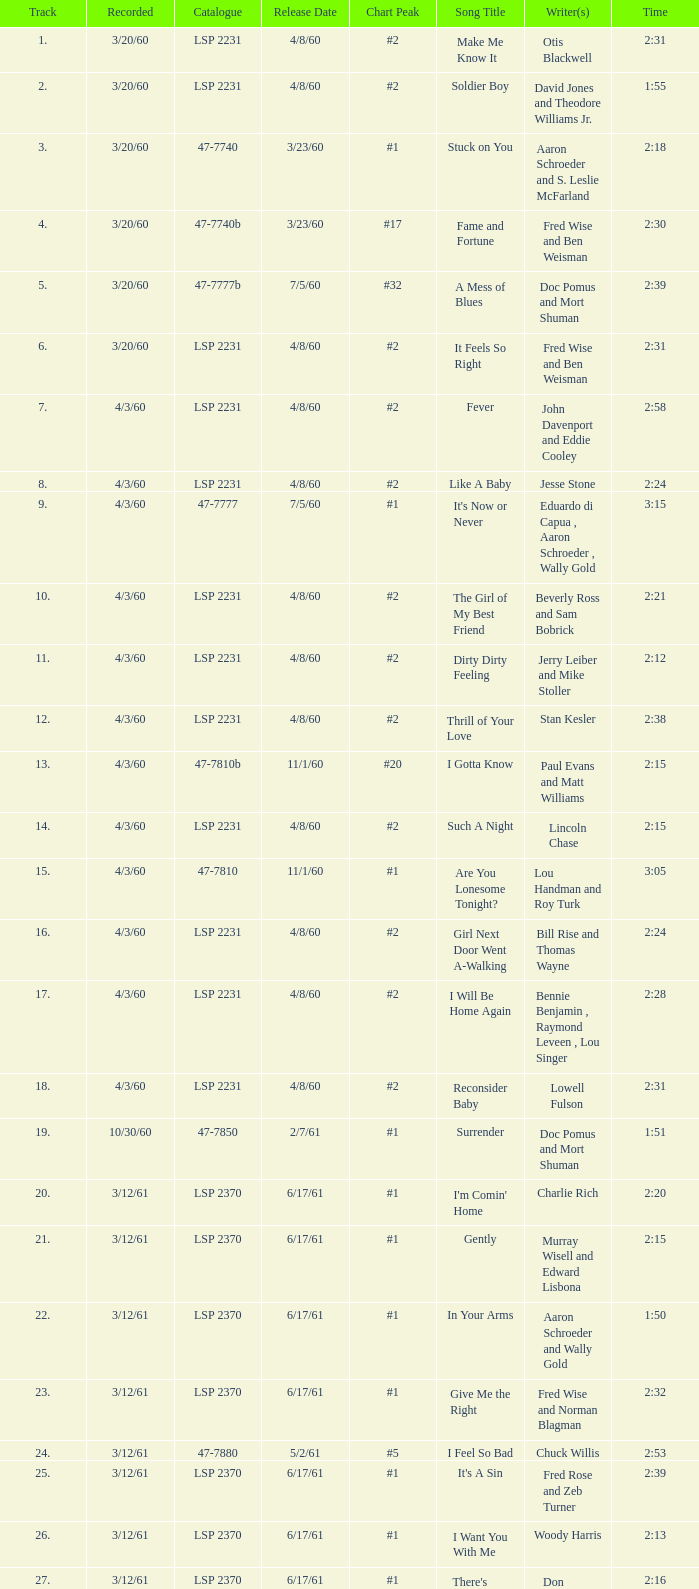On songs with track numbers smaller than number 17 and catalogues of LSP 2231, who are the writer(s)? Otis Blackwell, David Jones and Theodore Williams Jr., Fred Wise and Ben Weisman, John Davenport and Eddie Cooley, Jesse Stone, Beverly Ross and Sam Bobrick, Jerry Leiber and Mike Stoller, Stan Kesler, Lincoln Chase, Bill Rise and Thomas Wayne. Help me parse the entirety of this table. {'header': ['Track', 'Recorded', 'Catalogue', 'Release Date', 'Chart Peak', 'Song Title', 'Writer(s)', 'Time'], 'rows': [['1.', '3/20/60', 'LSP 2231', '4/8/60', '#2', 'Make Me Know It', 'Otis Blackwell', '2:31'], ['2.', '3/20/60', 'LSP 2231', '4/8/60', '#2', 'Soldier Boy', 'David Jones and Theodore Williams Jr.', '1:55'], ['3.', '3/20/60', '47-7740', '3/23/60', '#1', 'Stuck on You', 'Aaron Schroeder and S. Leslie McFarland', '2:18'], ['4.', '3/20/60', '47-7740b', '3/23/60', '#17', 'Fame and Fortune', 'Fred Wise and Ben Weisman', '2:30'], ['5.', '3/20/60', '47-7777b', '7/5/60', '#32', 'A Mess of Blues', 'Doc Pomus and Mort Shuman', '2:39'], ['6.', '3/20/60', 'LSP 2231', '4/8/60', '#2', 'It Feels So Right', 'Fred Wise and Ben Weisman', '2:31'], ['7.', '4/3/60', 'LSP 2231', '4/8/60', '#2', 'Fever', 'John Davenport and Eddie Cooley', '2:58'], ['8.', '4/3/60', 'LSP 2231', '4/8/60', '#2', 'Like A Baby', 'Jesse Stone', '2:24'], ['9.', '4/3/60', '47-7777', '7/5/60', '#1', "It's Now or Never", 'Eduardo di Capua , Aaron Schroeder , Wally Gold', '3:15'], ['10.', '4/3/60', 'LSP 2231', '4/8/60', '#2', 'The Girl of My Best Friend', 'Beverly Ross and Sam Bobrick', '2:21'], ['11.', '4/3/60', 'LSP 2231', '4/8/60', '#2', 'Dirty Dirty Feeling', 'Jerry Leiber and Mike Stoller', '2:12'], ['12.', '4/3/60', 'LSP 2231', '4/8/60', '#2', 'Thrill of Your Love', 'Stan Kesler', '2:38'], ['13.', '4/3/60', '47-7810b', '11/1/60', '#20', 'I Gotta Know', 'Paul Evans and Matt Williams', '2:15'], ['14.', '4/3/60', 'LSP 2231', '4/8/60', '#2', 'Such A Night', 'Lincoln Chase', '2:15'], ['15.', '4/3/60', '47-7810', '11/1/60', '#1', 'Are You Lonesome Tonight?', 'Lou Handman and Roy Turk', '3:05'], ['16.', '4/3/60', 'LSP 2231', '4/8/60', '#2', 'Girl Next Door Went A-Walking', 'Bill Rise and Thomas Wayne', '2:24'], ['17.', '4/3/60', 'LSP 2231', '4/8/60', '#2', 'I Will Be Home Again', 'Bennie Benjamin , Raymond Leveen , Lou Singer', '2:28'], ['18.', '4/3/60', 'LSP 2231', '4/8/60', '#2', 'Reconsider Baby', 'Lowell Fulson', '2:31'], ['19.', '10/30/60', '47-7850', '2/7/61', '#1', 'Surrender', 'Doc Pomus and Mort Shuman', '1:51'], ['20.', '3/12/61', 'LSP 2370', '6/17/61', '#1', "I'm Comin' Home", 'Charlie Rich', '2:20'], ['21.', '3/12/61', 'LSP 2370', '6/17/61', '#1', 'Gently', 'Murray Wisell and Edward Lisbona', '2:15'], ['22.', '3/12/61', 'LSP 2370', '6/17/61', '#1', 'In Your Arms', 'Aaron Schroeder and Wally Gold', '1:50'], ['23.', '3/12/61', 'LSP 2370', '6/17/61', '#1', 'Give Me the Right', 'Fred Wise and Norman Blagman', '2:32'], ['24.', '3/12/61', '47-7880', '5/2/61', '#5', 'I Feel So Bad', 'Chuck Willis', '2:53'], ['25.', '3/12/61', 'LSP 2370', '6/17/61', '#1', "It's A Sin", 'Fred Rose and Zeb Turner', '2:39'], ['26.', '3/12/61', 'LSP 2370', '6/17/61', '#1', 'I Want You With Me', 'Woody Harris', '2:13'], ['27.', '3/12/61', 'LSP 2370', '6/17/61', '#1', "There's Always Me", 'Don Robertson', '2:16']]} 